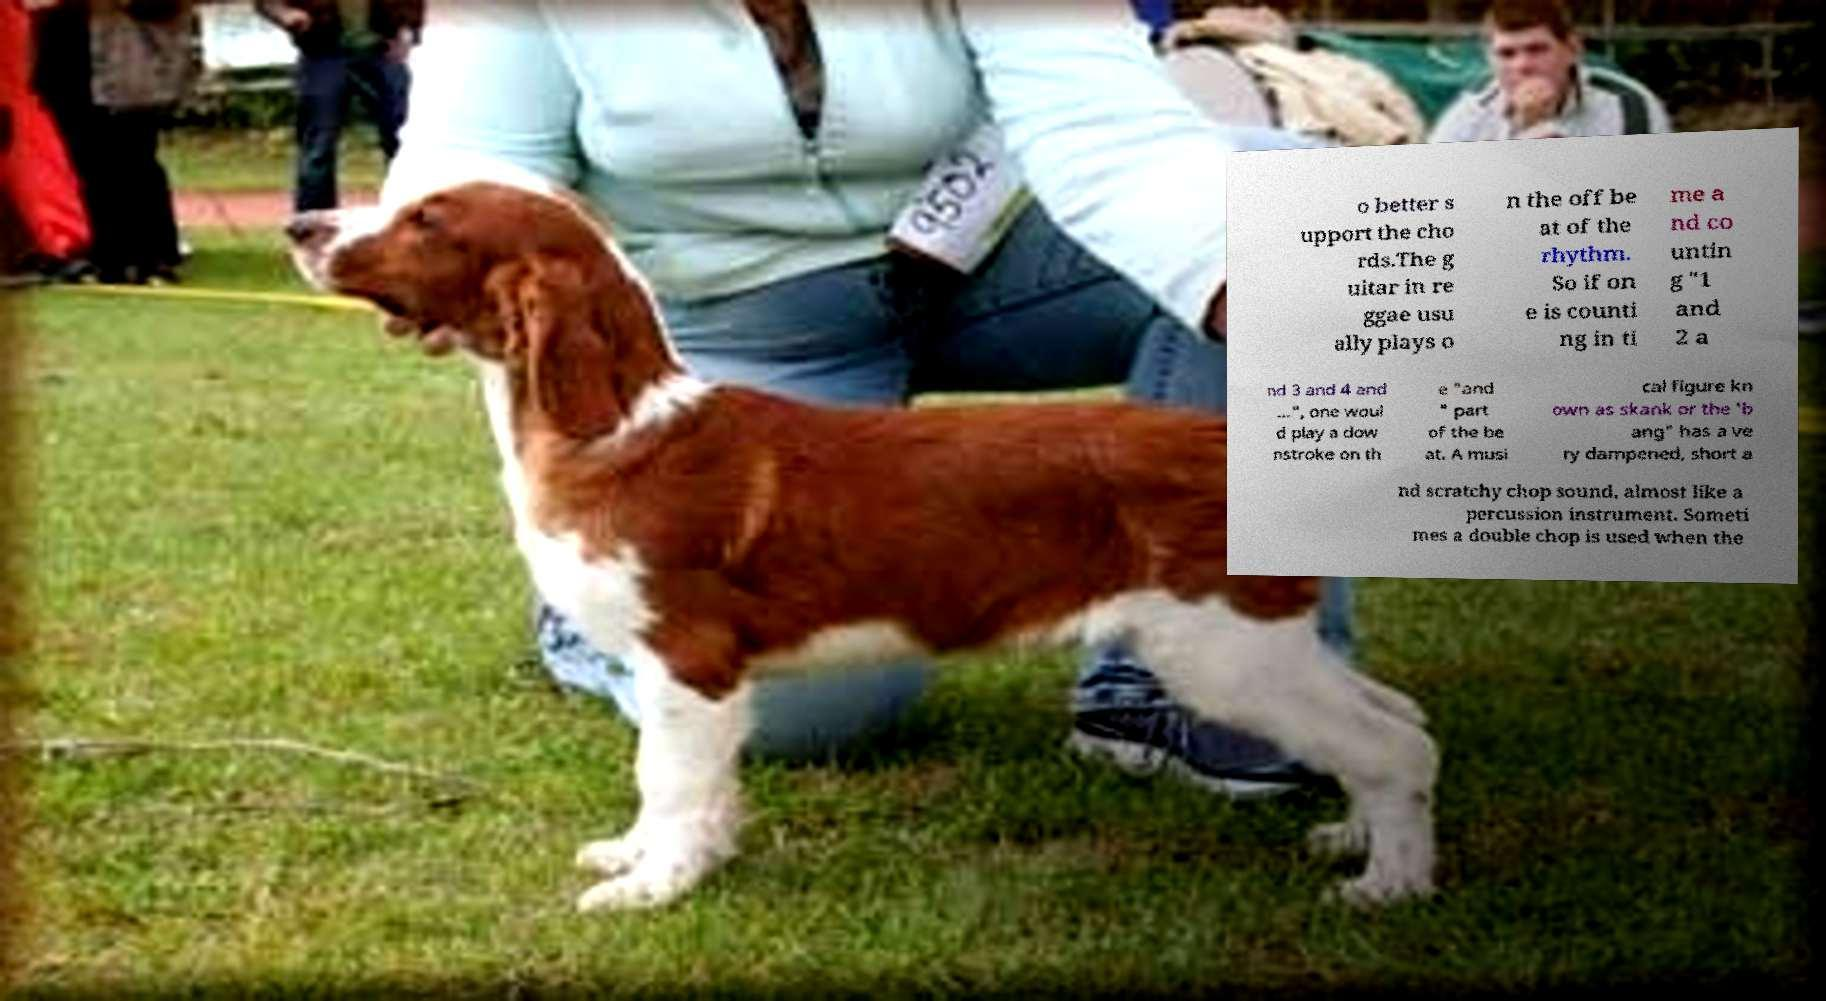There's text embedded in this image that I need extracted. Can you transcribe it verbatim? o better s upport the cho rds.The g uitar in re ggae usu ally plays o n the off be at of the rhythm. So if on e is counti ng in ti me a nd co untin g "1 and 2 a nd 3 and 4 and ...", one woul d play a dow nstroke on th e "and " part of the be at. A musi cal figure kn own as skank or the 'b ang" has a ve ry dampened, short a nd scratchy chop sound, almost like a percussion instrument. Someti mes a double chop is used when the 